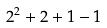Convert formula to latex. <formula><loc_0><loc_0><loc_500><loc_500>2 ^ { 2 } + 2 + 1 - 1</formula> 